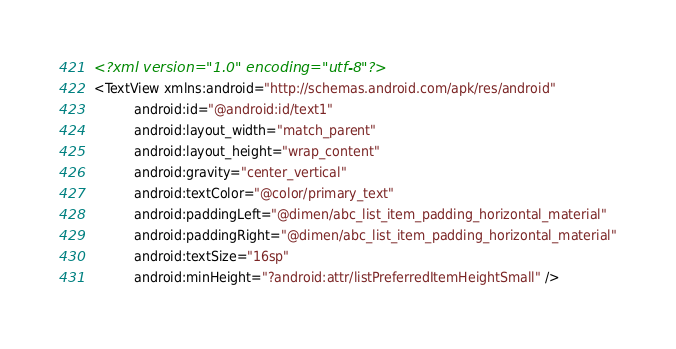Convert code to text. <code><loc_0><loc_0><loc_500><loc_500><_XML_><?xml version="1.0" encoding="utf-8"?>
<TextView xmlns:android="http://schemas.android.com/apk/res/android"
          android:id="@android:id/text1"
          android:layout_width="match_parent"
          android:layout_height="wrap_content"
          android:gravity="center_vertical"
          android:textColor="@color/primary_text"
          android:paddingLeft="@dimen/abc_list_item_padding_horizontal_material"
          android:paddingRight="@dimen/abc_list_item_padding_horizontal_material"
          android:textSize="16sp"
          android:minHeight="?android:attr/listPreferredItemHeightSmall" /></code> 